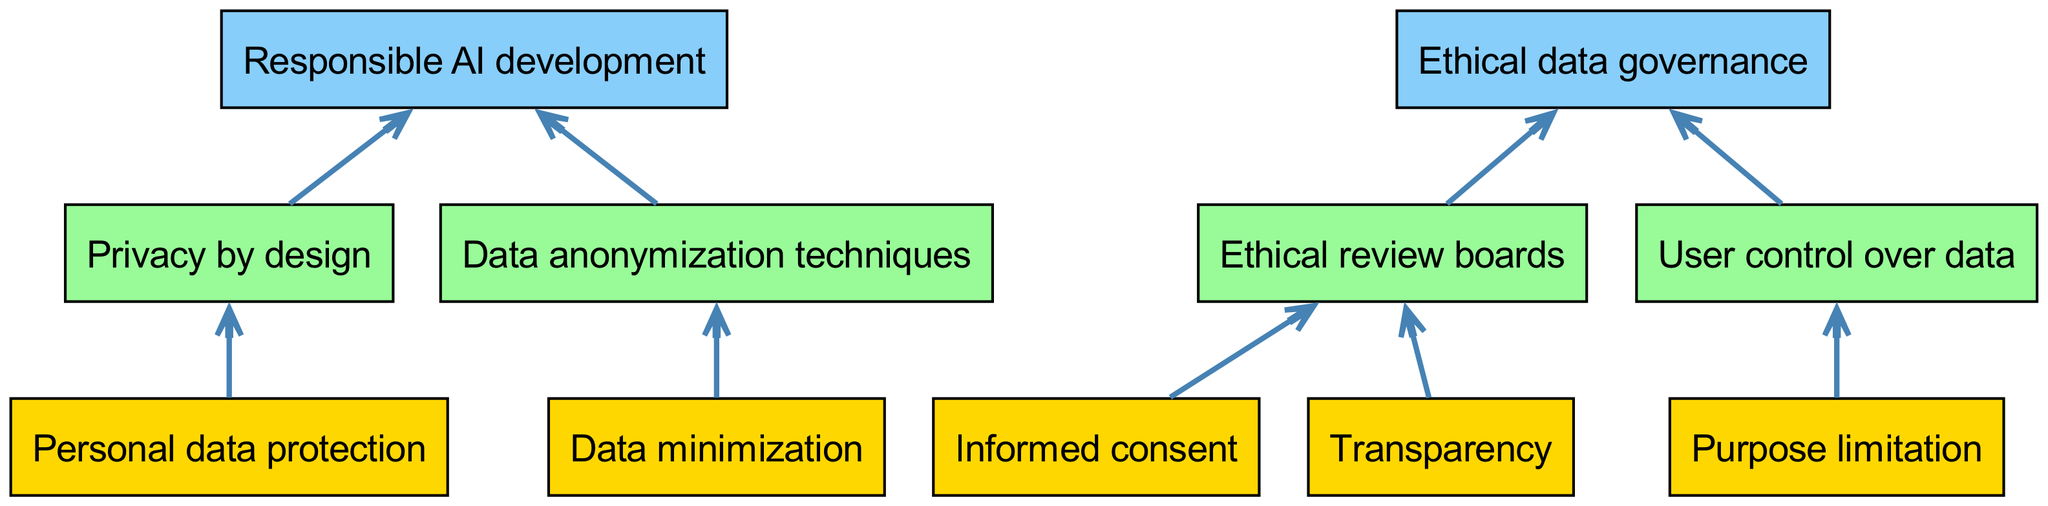What are the bottom elements of this diagram? The bottom elements listed in the diagram are Personal data protection, Informed consent, Data minimization, Purpose limitation, and Transparency. This information is directly visible in the bottom section of the flowchart.
Answer: Personal data protection, Informed consent, Data minimization, Purpose limitation, Transparency How many middle elements are there? The diagram shows four middle elements: Privacy by design, Ethical review boards, Data anonymization techniques, and User control over data. Counting these elements gives a total of four.
Answer: 4 What is the relationship between Informed consent and Ethical review boards? According to the diagram, there is a direct connection from Informed consent to Ethical review boards, indicating that informed consent is considered in the ethical review process.
Answer: Direct connection Which element leads to Responsible AI development? The diagram shows that both Privacy by design and Data anonymization techniques lead to Responsible AI development. This indicates that these two elements are vital for developing responsible AI practices.
Answer: Privacy by design, Data anonymization techniques How many connections are illustrated in the diagram? The diagram depicts eight connections between the elements, which represent the relationships forming the flow of ethical considerations in data collection practices. Counting these connections verifies that there are eight.
Answer: 8 If Data minimization is applied, what technique is promoted? The diagram indicates that applying Data minimization leads to the use of Data anonymization techniques, showcasing how reducing data usage encourages anonymization for privacy.
Answer: Data anonymization techniques Which top element is connected to Ethical review boards? The diagram illustrates that Ethical review boards lead to Ethical data governance, indicating that input from ethical review processes plays a key role in establishing data governance frameworks.
Answer: Ethical data governance What flows from Transparency in the diagram? The diagram shows that Transparency connects to Ethical review boards, suggesting a relationship where transparency in data practices influences ethical oversight.
Answer: Ethical review boards 